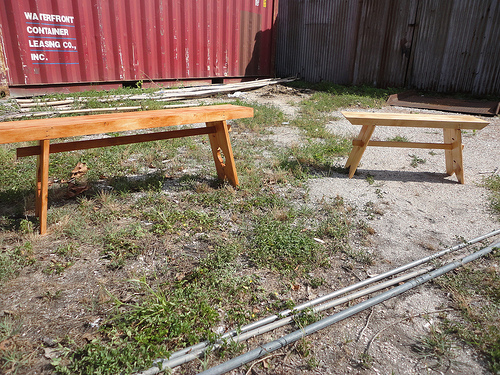<image>
Is the poles behind the table? No. The poles is not behind the table. From this viewpoint, the poles appears to be positioned elsewhere in the scene. 